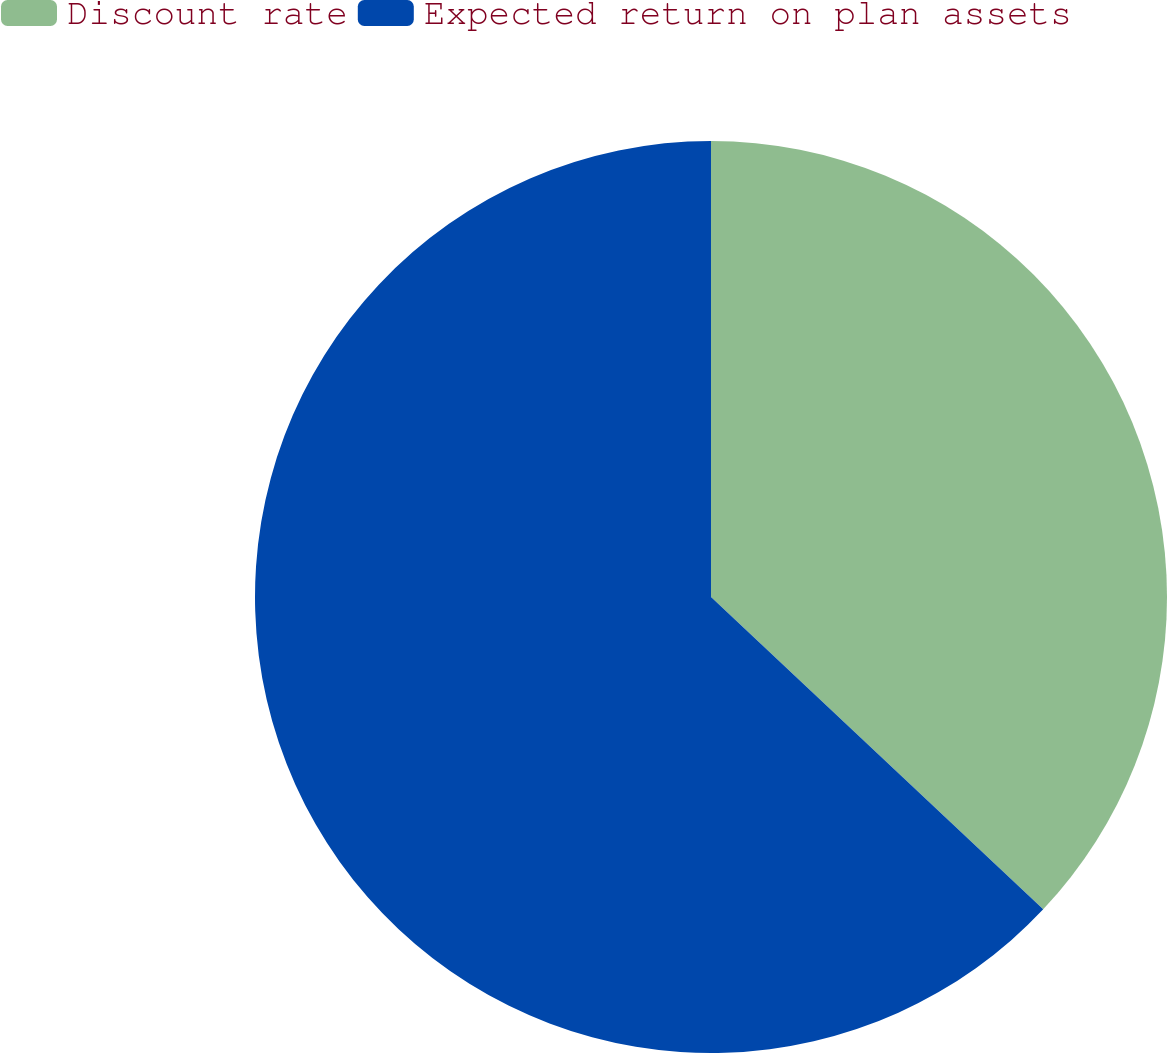Convert chart. <chart><loc_0><loc_0><loc_500><loc_500><pie_chart><fcel>Discount rate<fcel>Expected return on plan assets<nl><fcel>37.01%<fcel>62.99%<nl></chart> 